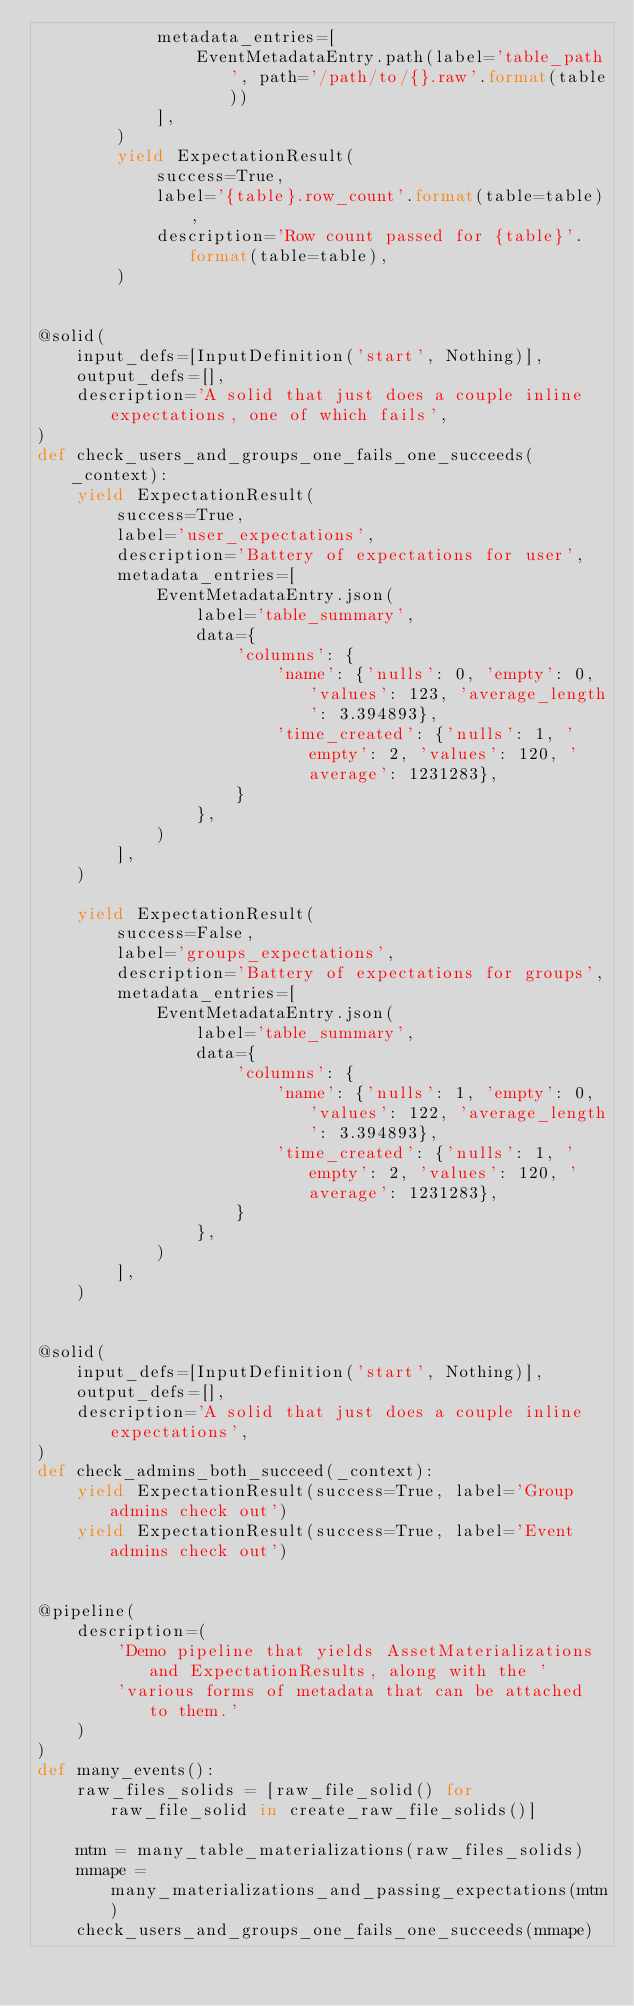<code> <loc_0><loc_0><loc_500><loc_500><_Python_>            metadata_entries=[
                EventMetadataEntry.path(label='table_path', path='/path/to/{}.raw'.format(table))
            ],
        )
        yield ExpectationResult(
            success=True,
            label='{table}.row_count'.format(table=table),
            description='Row count passed for {table}'.format(table=table),
        )


@solid(
    input_defs=[InputDefinition('start', Nothing)],
    output_defs=[],
    description='A solid that just does a couple inline expectations, one of which fails',
)
def check_users_and_groups_one_fails_one_succeeds(_context):
    yield ExpectationResult(
        success=True,
        label='user_expectations',
        description='Battery of expectations for user',
        metadata_entries=[
            EventMetadataEntry.json(
                label='table_summary',
                data={
                    'columns': {
                        'name': {'nulls': 0, 'empty': 0, 'values': 123, 'average_length': 3.394893},
                        'time_created': {'nulls': 1, 'empty': 2, 'values': 120, 'average': 1231283},
                    }
                },
            )
        ],
    )

    yield ExpectationResult(
        success=False,
        label='groups_expectations',
        description='Battery of expectations for groups',
        metadata_entries=[
            EventMetadataEntry.json(
                label='table_summary',
                data={
                    'columns': {
                        'name': {'nulls': 1, 'empty': 0, 'values': 122, 'average_length': 3.394893},
                        'time_created': {'nulls': 1, 'empty': 2, 'values': 120, 'average': 1231283},
                    }
                },
            )
        ],
    )


@solid(
    input_defs=[InputDefinition('start', Nothing)],
    output_defs=[],
    description='A solid that just does a couple inline expectations',
)
def check_admins_both_succeed(_context):
    yield ExpectationResult(success=True, label='Group admins check out')
    yield ExpectationResult(success=True, label='Event admins check out')


@pipeline(
    description=(
        'Demo pipeline that yields AssetMaterializations and ExpectationResults, along with the '
        'various forms of metadata that can be attached to them.'
    )
)
def many_events():
    raw_files_solids = [raw_file_solid() for raw_file_solid in create_raw_file_solids()]

    mtm = many_table_materializations(raw_files_solids)
    mmape = many_materializations_and_passing_expectations(mtm)
    check_users_and_groups_one_fails_one_succeeds(mmape)</code> 